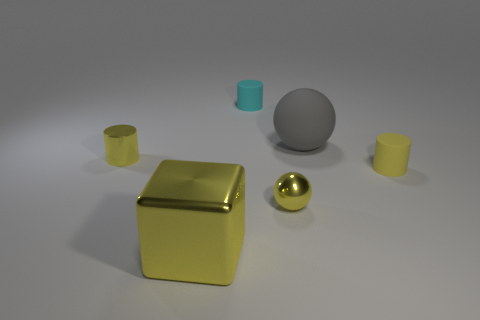How many metal things have the same color as the small sphere?
Provide a succinct answer. 2. There is a cyan thing that is behind the small yellow shiny sphere; what material is it?
Provide a short and direct response. Rubber. What is the color of the ball that is made of the same material as the cyan cylinder?
Your answer should be compact. Gray. How many metallic things are either spheres or large yellow cubes?
Provide a short and direct response. 2. The other matte thing that is the same size as the cyan object is what shape?
Offer a very short reply. Cylinder. How many objects are either cylinders on the right side of the yellow metallic cylinder or yellow cylinders that are left of the cyan cylinder?
Provide a short and direct response. 3. What is the material of the yellow sphere that is the same size as the cyan thing?
Offer a terse response. Metal. How many other things are the same material as the cyan cylinder?
Make the answer very short. 2. Are there an equal number of tiny yellow shiny balls that are to the right of the large shiny object and cyan things that are left of the metallic cylinder?
Your answer should be compact. No. How many yellow things are small matte objects or tiny metal cylinders?
Keep it short and to the point. 2. 